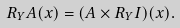Convert formula to latex. <formula><loc_0><loc_0><loc_500><loc_500>R _ { Y } A ( x ) = ( A \times R _ { Y } I ) ( x ) .</formula> 